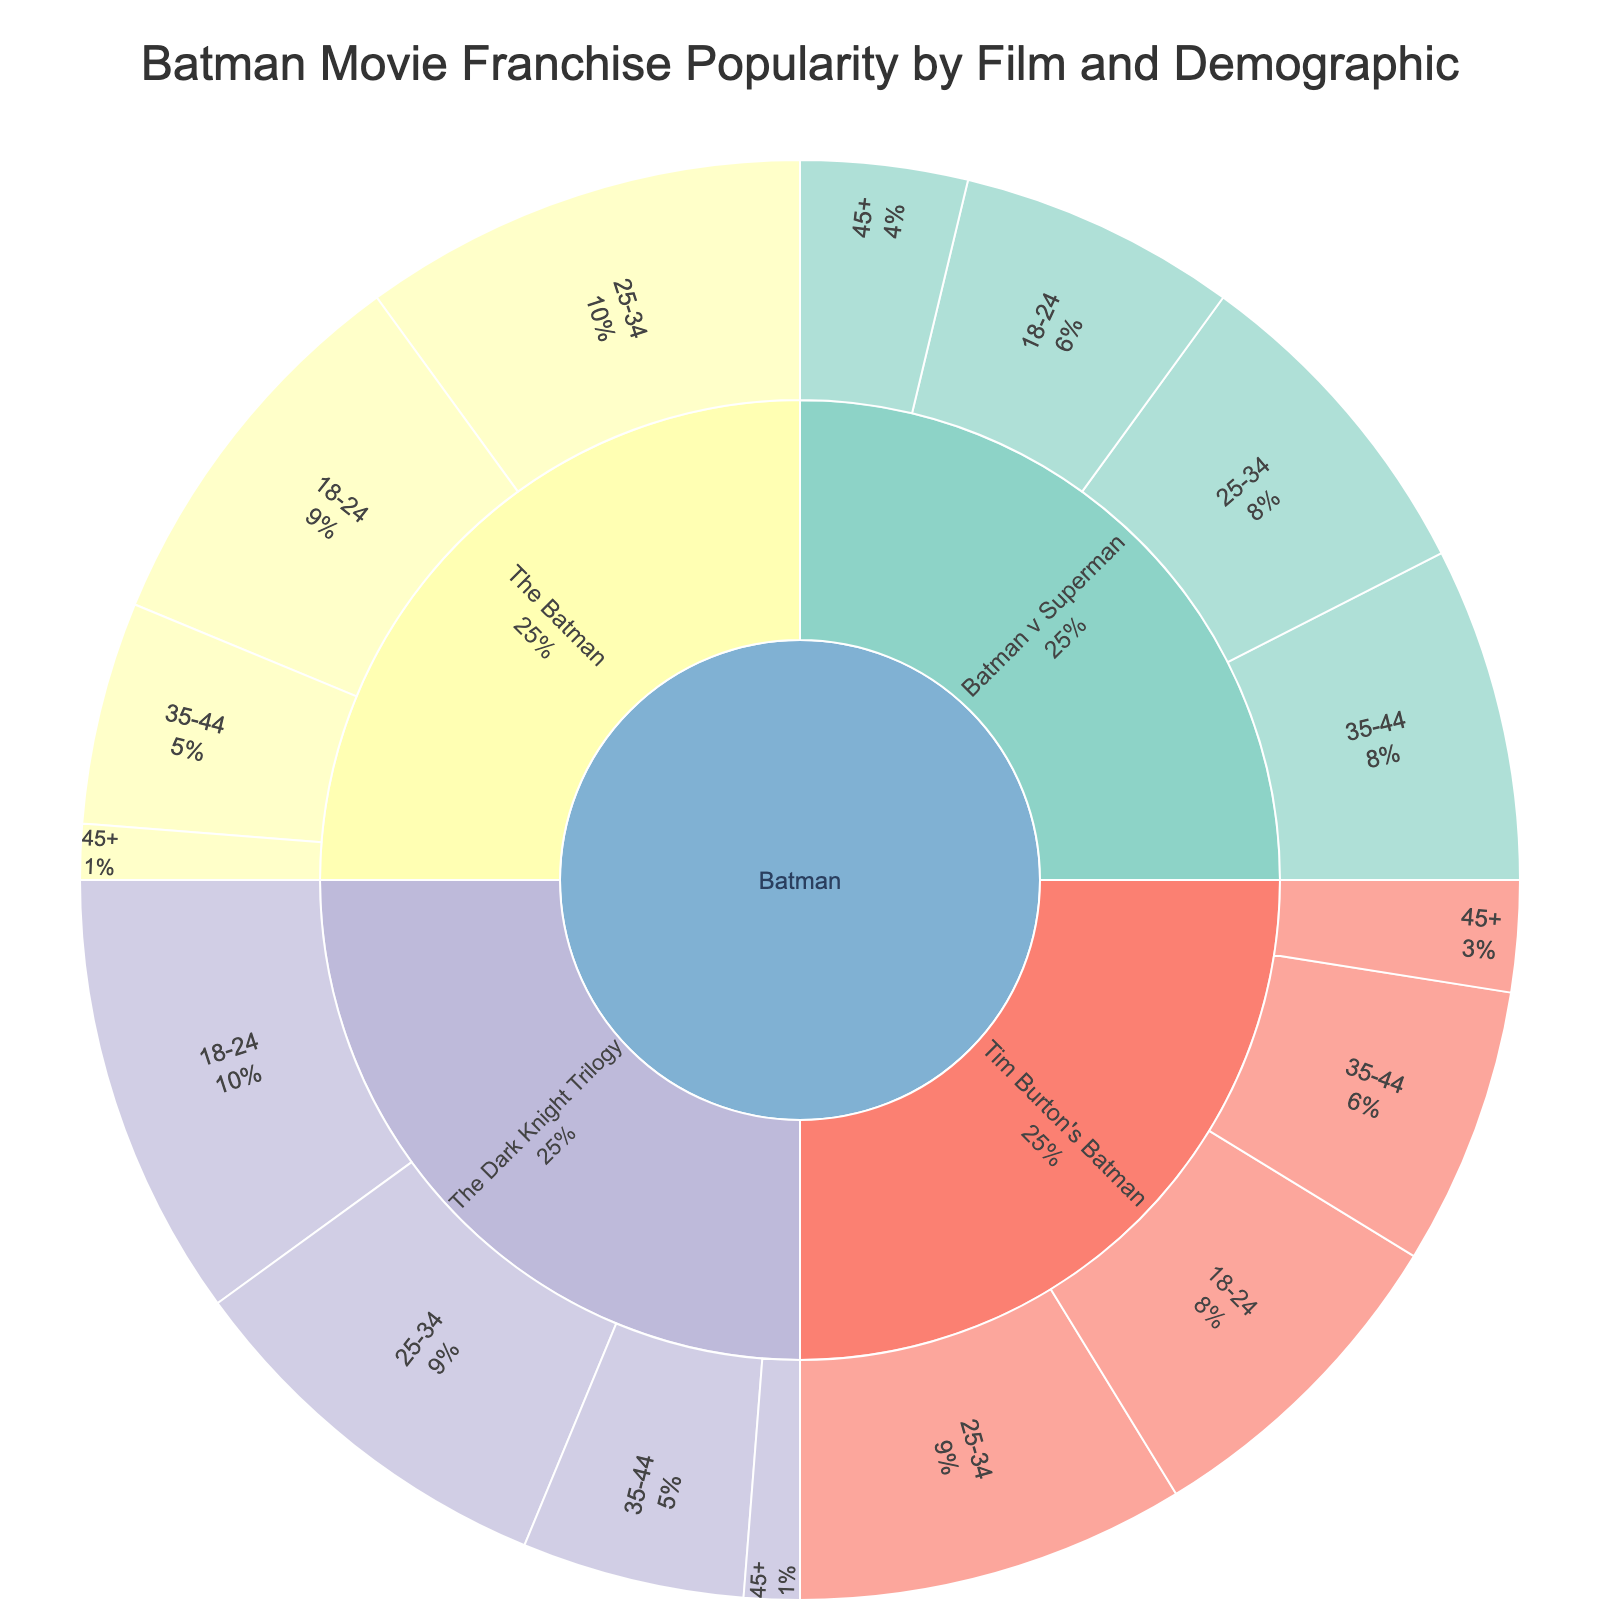What's the title of the sunburst plot? The title is typically displayed at the top of the plot, indicating the main subject or theme of the visualization. In this plot, the title is: "Batman Movie Franchise Popularity by Film and Demographic."
Answer: Batman Movie Franchise Popularity by Film and Demographic Which film iteration has the highest overall popularity among the 18-24 demographic? To find this, look at the section for each film within the 18-24 demographic and identify the one with the largest value. According to the data, "The Dark Knight Trilogy" has the highest value (40) in the 18-24 category.
Answer: The Dark Knight Trilogy What is the sum of the popularity values for the 25-34 demographic across all films? To compute this, sum the values for the 25-34 demographic across each film iteration: 35 (Tim Burton's Batman) + 35 (The Dark Knight Trilogy) + 30 (Batman v Superman) + 40 (The Batman). The total is 140.
Answer: 140 Which film iteration has the least popularity among audiences aged 45 and above? Identify the smallest value within the 45+ demographic from each film iteration: 10 (Tim Burton's Batman), 5 (The Dark Knight Trilogy), 15 (Batman v Superman), and 5 (The Batman). The smallest value is 5, occurring in "The Dark Knight Trilogy" and "The Batman."
Answer: The Dark Knight Trilogy and The Batman Comparing the 35-44 demographic, which film iteration has higher popularity: "Tim Burton's Batman" or "Batman v Superman"? Examine the values for the 35-44 demographic for both films: 25 (Tim Burton's Batman) and 30 (Batman v Superman). "Batman v Superman" has a higher value.
Answer: Batman v Superman What is the average popularity value for "The Batman" across all demographics? Calculate the mean value by summing up the values for "The Batman" and dividing by the number of demographics: (35 + 40 + 20 + 5) / 4. The sum is 100, and the average is 100/4 = 25.
Answer: 25 Which demographic group has the lowest overall interest in Batman movies? By inspecting the outer ring, identify the group with the lowest cumulative value. The 45+ demographic consistently has the smallest slices in each film iteration.
Answer: 45+ What is the value difference between the 18-24 and 35-44 demographics for "The Dark Knight Trilogy"? To find the difference, subtract the value for the 35-44 demographic from the 18-24 demographic within "The Dark Knight Trilogy": 40 (18-24) - 20 (35-44) = 20.
Answer: 20 Are there any demographics where "Tim Burton's Batman" and "The Batman" have the same popularity values? Compare the values across demographics for both films. In the case of the 45+ demographic, both have a value of 10 ("Tim Burton's Batman") and 5 ("The Batman"). They do not match any demographic exactly.
Answer: No 